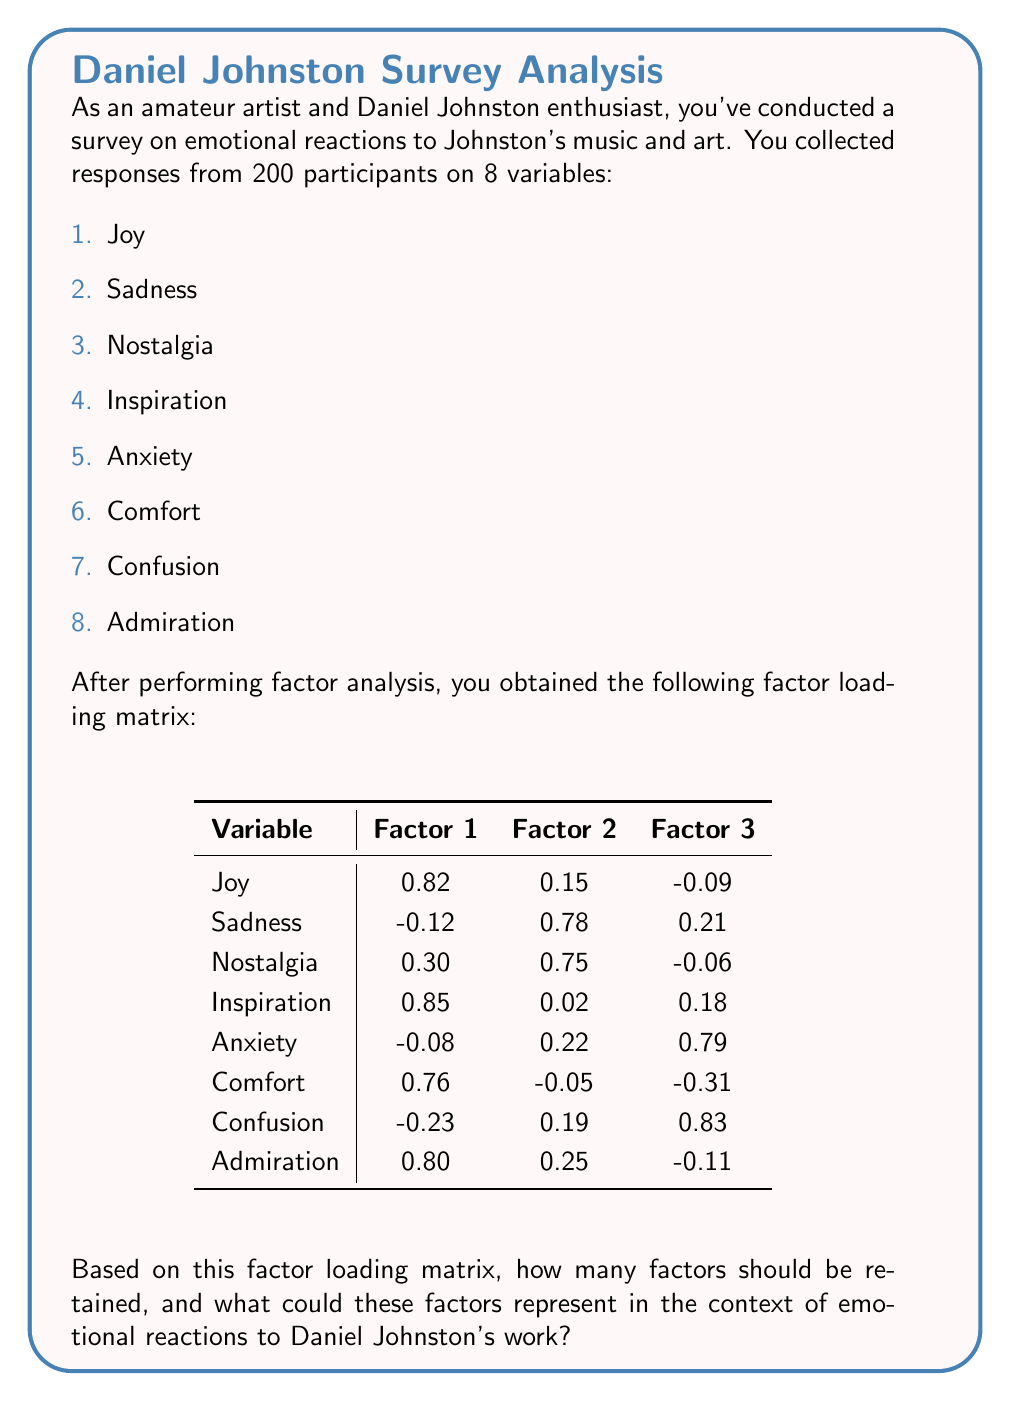Solve this math problem. To determine the number of factors to retain and interpret their meaning, we'll follow these steps:

1. Examine the factor loadings:
   - Factor loadings above 0.7 are considered high and indicate strong correlation with the factor.
   - Loadings between 0.4 and 0.7 are moderate.
   - Loadings below 0.4 are generally considered weak.

2. Identify variables with high loadings for each factor:

   Factor 1:
   - Joy (0.82)
   - Inspiration (0.85)
   - Comfort (0.76)
   - Admiration (0.80)

   Factor 2:
   - Sadness (0.78)
   - Nostalgia (0.75)

   Factor 3:
   - Anxiety (0.79)
   - Confusion (0.83)

3. Interpret the factors based on the variables they represent:

   Factor 1: This factor has high positive loadings for Joy, Inspiration, Comfort, and Admiration. These emotions are generally positive and uplifting. We could label this factor as "Positive Emotional Response" or "Uplift."

   Factor 2: This factor has high positive loadings for Sadness and Nostalgia. These emotions are related to reflection and melancholy. We could label this factor as "Melancholic Reflection."

   Factor 3: This factor has high positive loadings for Anxiety and Confusion. These emotions relate to uncertainty or discomfort. We could label this factor as "Emotional Discomfort" or "Uncertainty."

4. Determine the number of factors to retain:
   - All three factors have at least two variables with high loadings (>0.7).
   - Each factor represents a distinct aspect of emotional response to Johnston's work.
   - The factors are interpretable and meaningful in the context of art appreciation.

Therefore, it is appropriate to retain all three factors in this analysis.
Answer: Retain 3 factors: 1) Positive Emotional Response, 2) Melancholic Reflection, 3) Emotional Discomfort 